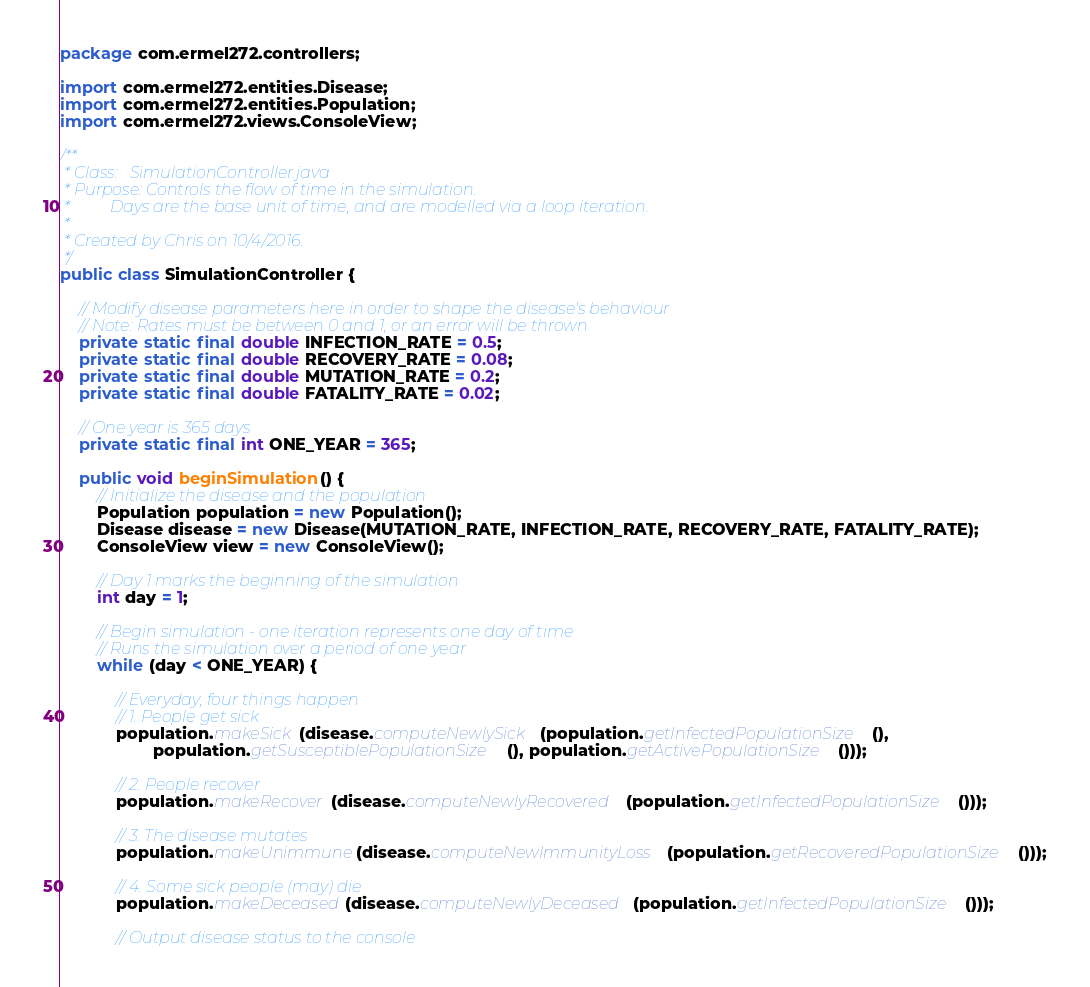<code> <loc_0><loc_0><loc_500><loc_500><_Java_>package com.ermel272.controllers;

import com.ermel272.entities.Disease;
import com.ermel272.entities.Population;
import com.ermel272.views.ConsoleView;

/**
 * Class:   SimulationController.java
 * Purpose: Controls the flow of time in the simulation.
 *          Days are the base unit of time, and are modelled via a loop iteration.
 *
 * Created by Chris on 10/4/2016.
 */
public class SimulationController {

    // Modify disease parameters here in order to shape the disease's behaviour
    // Note: Rates must be between 0 and 1, or an error will be thrown
    private static final double INFECTION_RATE = 0.5;
    private static final double RECOVERY_RATE = 0.08;
    private static final double MUTATION_RATE = 0.2;
    private static final double FATALITY_RATE = 0.02;

    // One year is 365 days
    private static final int ONE_YEAR = 365;

    public void beginSimulation() {
        // Initialize the disease and the population
        Population population = new Population();
        Disease disease = new Disease(MUTATION_RATE, INFECTION_RATE, RECOVERY_RATE, FATALITY_RATE);
        ConsoleView view = new ConsoleView();

        // Day 1 marks the beginning of the simulation
        int day = 1;

        // Begin simulation - one iteration represents one day of time
        // Runs the simulation over a period of one year
        while (day < ONE_YEAR) {

            // Everyday, four things happen
            // 1. People get sick
            population.makeSick(disease.computeNewlySick(population.getInfectedPopulationSize(),
                    population.getSusceptiblePopulationSize(), population.getActivePopulationSize()));

            // 2. People recover
            population.makeRecover(disease.computeNewlyRecovered(population.getInfectedPopulationSize()));

            // 3. The disease mutates
            population.makeUnimmune(disease.computeNewImmunityLoss(population.getRecoveredPopulationSize()));

            // 4. Some sick people (may) die
            population.makeDeceased(disease.computeNewlyDeceased(population.getInfectedPopulationSize()));

            // Output disease status to the console</code> 